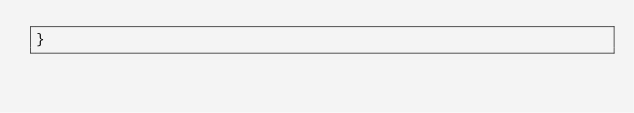Convert code to text. <code><loc_0><loc_0><loc_500><loc_500><_Java_>}
</code> 